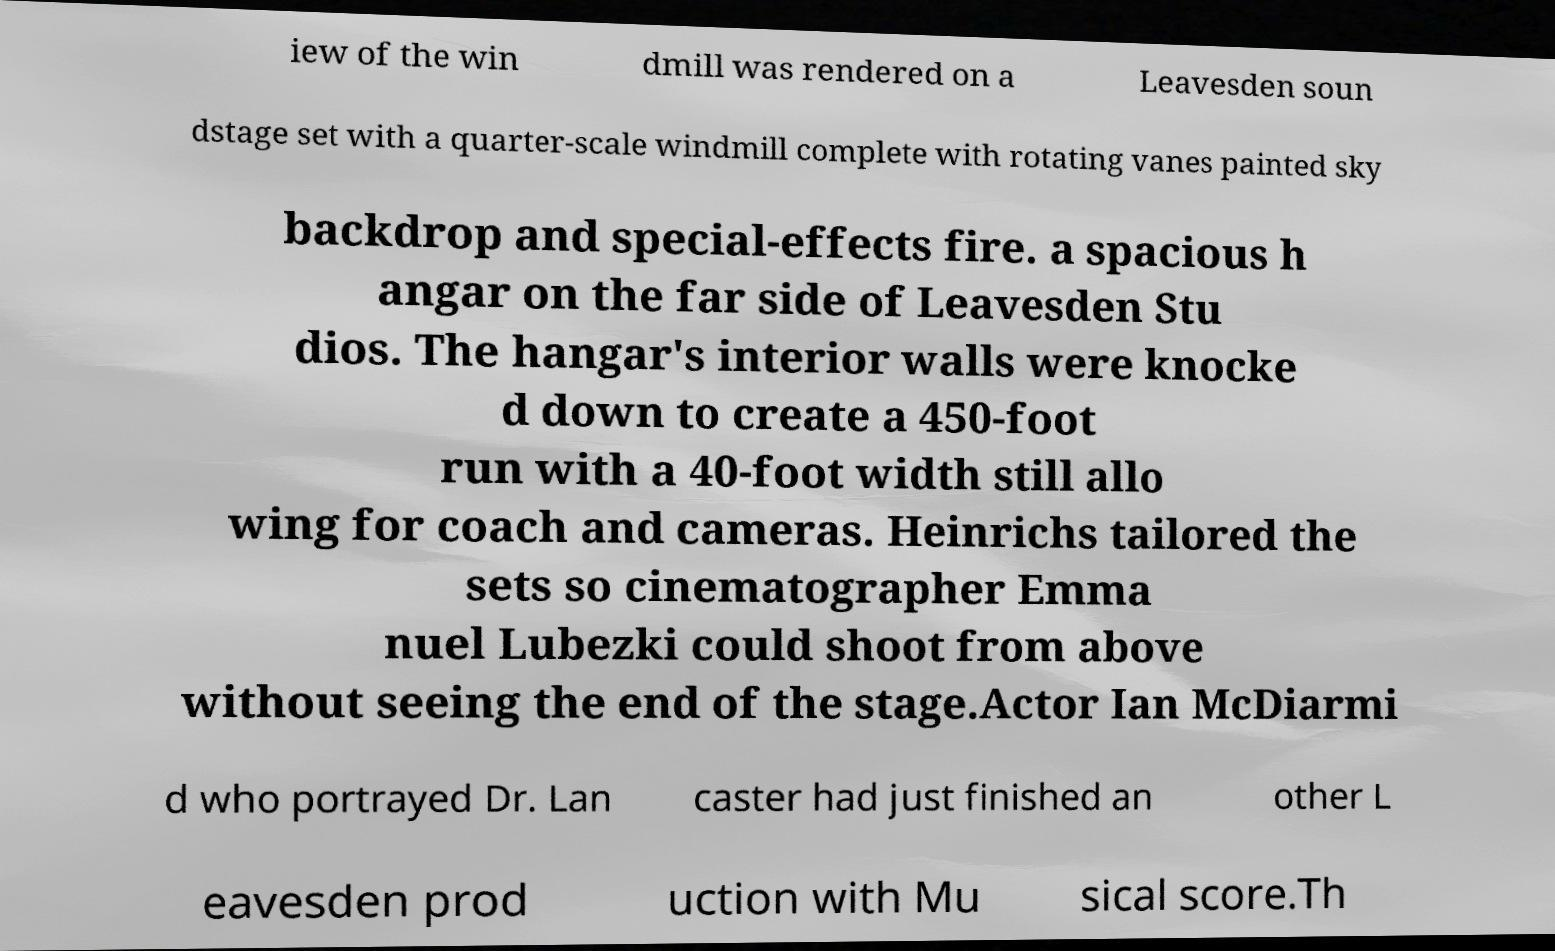Please read and relay the text visible in this image. What does it say? iew of the win dmill was rendered on a Leavesden soun dstage set with a quarter-scale windmill complete with rotating vanes painted sky backdrop and special-effects fire. a spacious h angar on the far side of Leavesden Stu dios. The hangar's interior walls were knocke d down to create a 450-foot run with a 40-foot width still allo wing for coach and cameras. Heinrichs tailored the sets so cinematographer Emma nuel Lubezki could shoot from above without seeing the end of the stage.Actor Ian McDiarmi d who portrayed Dr. Lan caster had just finished an other L eavesden prod uction with Mu sical score.Th 